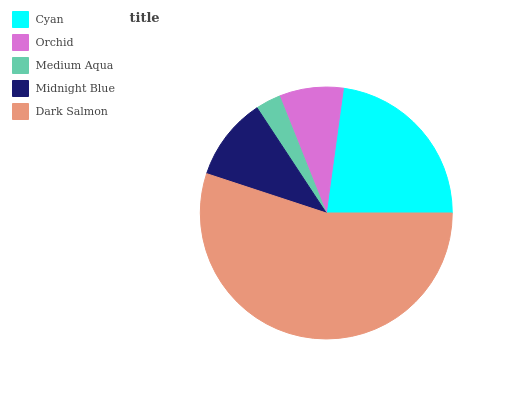Is Medium Aqua the minimum?
Answer yes or no. Yes. Is Dark Salmon the maximum?
Answer yes or no. Yes. Is Orchid the minimum?
Answer yes or no. No. Is Orchid the maximum?
Answer yes or no. No. Is Cyan greater than Orchid?
Answer yes or no. Yes. Is Orchid less than Cyan?
Answer yes or no. Yes. Is Orchid greater than Cyan?
Answer yes or no. No. Is Cyan less than Orchid?
Answer yes or no. No. Is Midnight Blue the high median?
Answer yes or no. Yes. Is Midnight Blue the low median?
Answer yes or no. Yes. Is Orchid the high median?
Answer yes or no. No. Is Orchid the low median?
Answer yes or no. No. 